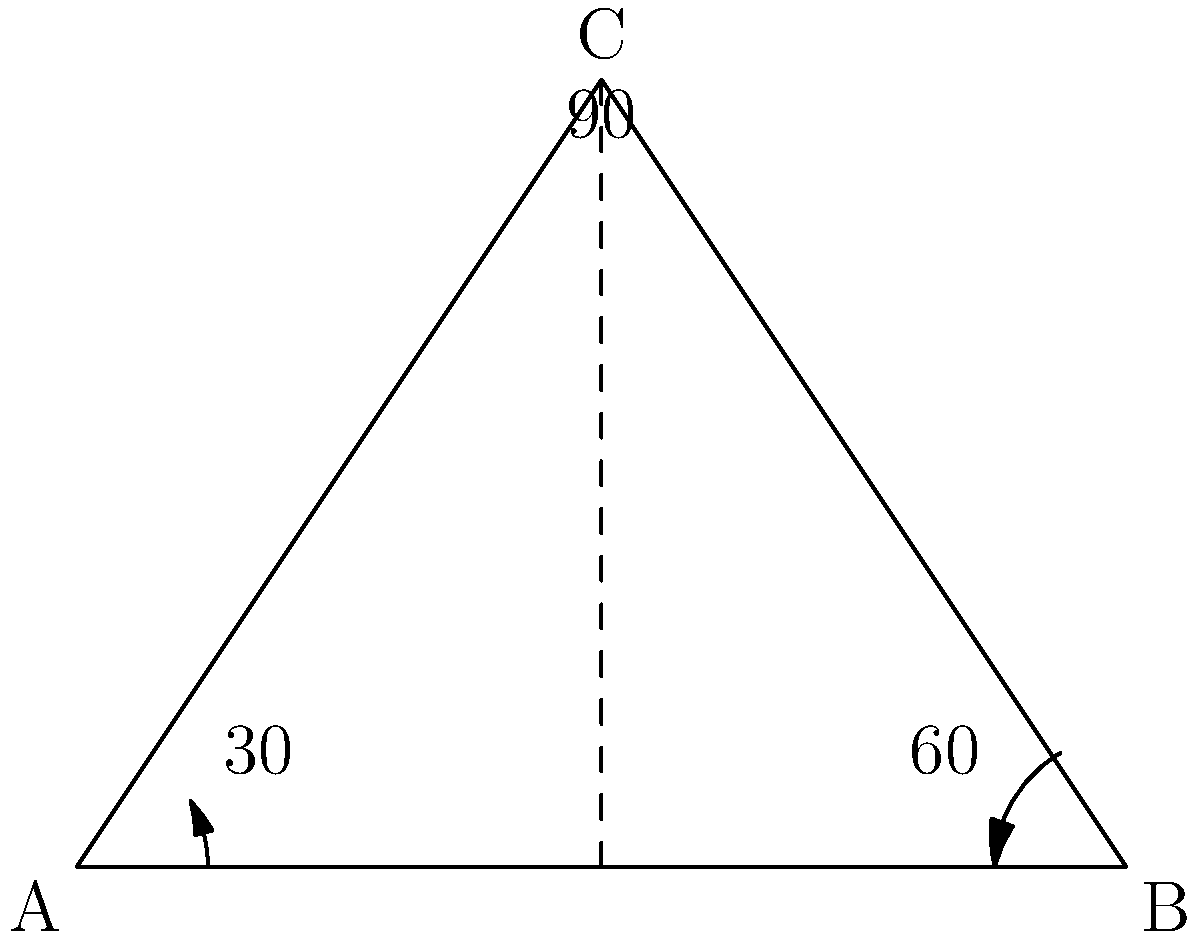In a film set, you're using a triangular reflector to achieve a specific lighting effect. The reflector forms a right-angled triangle ABC, where angle C is 90°. If the angle of incidence of the light on side AB is 30°, what is the angle of reflection on side BC to create the desired effect? Let's approach this step-by-step:

1) In a right-angled triangle, we know that the sum of all angles is 180°.

2) Given: 
   - Angle C = 90° (right angle)
   - Angle at A = 30° (angle of incidence)

3) Let's call the angle at B as x°.

4) Using the triangle angle sum theorem:
   $$30° + 90° + x° = 180°$$

5) Simplify:
   $$120° + x° = 180°$$

6) Solve for x:
   $$x° = 180° - 120° = 60°$$

7) Now, we know that the angle of incidence equals the angle of reflection.

8) The angle of reflection on side BC will be the same as the angle at B, which we just calculated as 60°.

Therefore, the angle of reflection on side BC is 60°.
Answer: 60° 